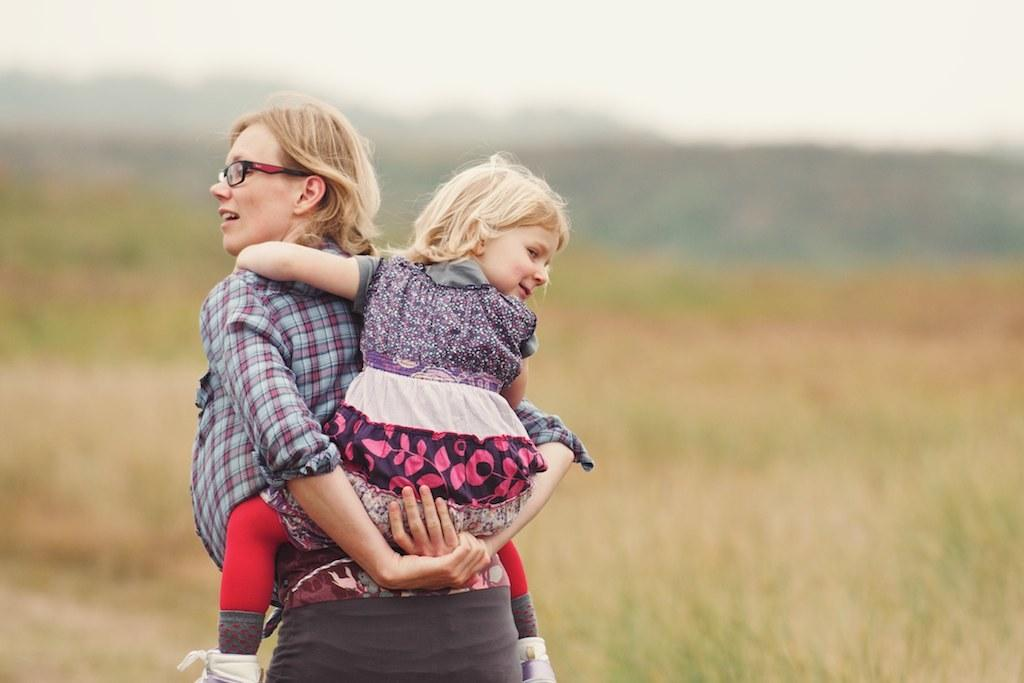Who is the main subject in the image? There is a woman in the image. What is the woman wearing? The woman is wearing spectacles. What is the woman doing in the image? The woman is carrying a girl. What can be seen in the background of the image? There is grass, mountains, and the sky visible in the background of the image. How would you describe the quality of the image? The image appears to be blurry. What type of corn can be seen growing in the woman's pocket in the image? There is no corn visible in the image, and the woman is not shown to have a pocket. 